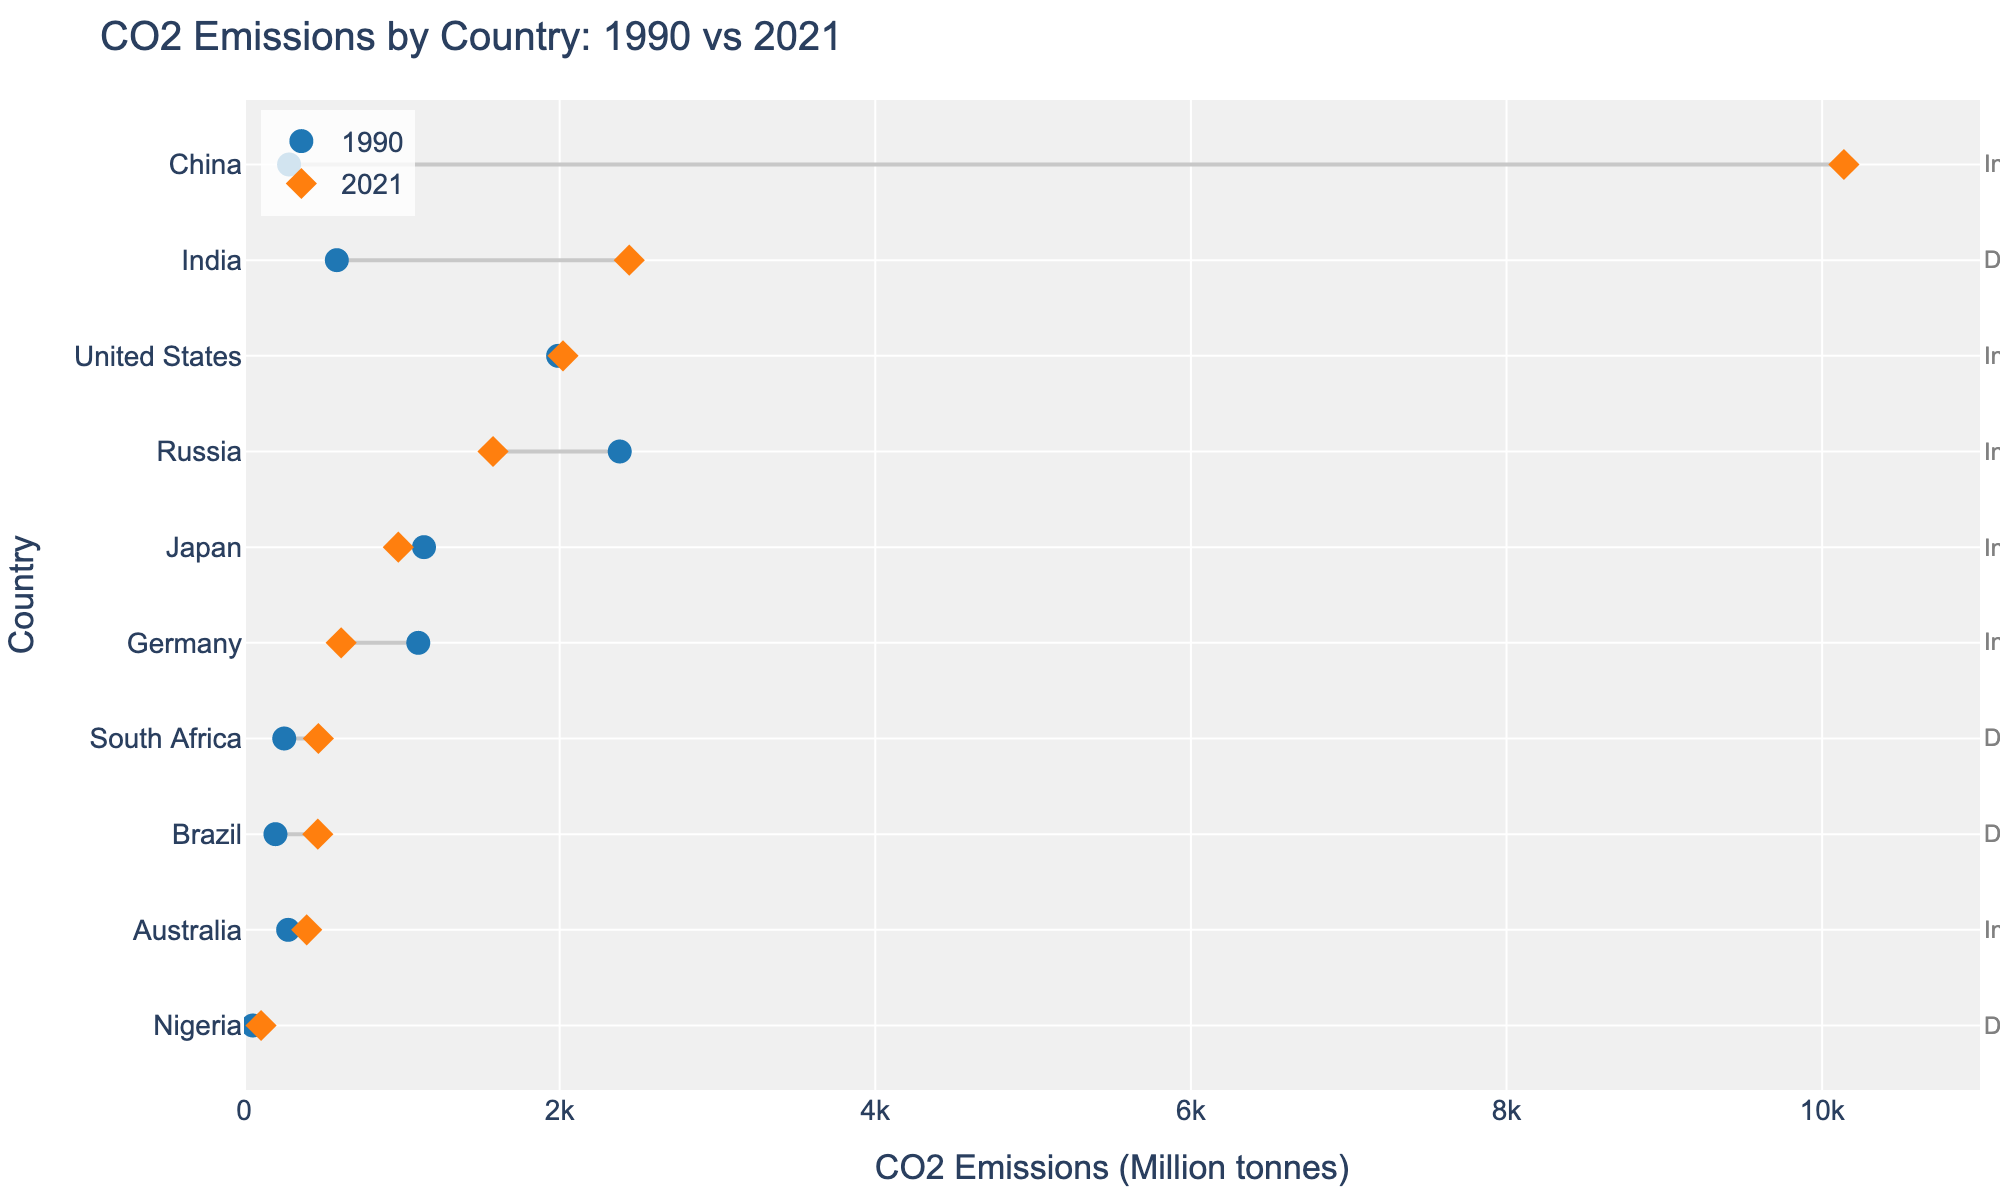What is the title of the plot? The title of the plot is written at the top and reads "CO2 Emissions by Country: 1990 vs 2021".
Answer: CO2 Emissions by Country: 1990 vs 2021 Which country had the highest CO2 emissions in 2021? By looking at the position on the x-axis, China is the farthest right on the plot, indicating it had the highest CO2 emissions in 2021.
Answer: China What is the color of the markers indicating CO2 emissions in 1990? The markers for 1990 are a specific shade of blue, which differentiates them from other data points.
Answer: Blue How many countries have been categorized as developing? The plot shows country annotations on the far right side of the plot. Counting the annotations labeled "Developing" gives us the total number of those countries.
Answer: 4 Which country had the largest increase in CO2 emissions between 1990 and 2021? To find the largest increase, we look at the length of the lines connecting the blue and orange markers. China has the longest line, indicating the biggest increase.
Answer: China Which industrial country reduced its CO2 emissions from 1990 to 2021? Identifying the countries with downward-sloping lines (from left to right) among those labeled as "Industrial" reveals Germany as the country that reduced its emissions.
Answer: Germany Between Brazil and South Africa, which country had a higher CO2 emission in 1990? By comparing the blue markers for Brazil and South Africa on the x-axis, Brazil's point appears further to the right, indicating higher emissions.
Answer: Brazil What is the difference in CO2 emissions between Russia and the United States in 1990? The plot shows the 1990 emissions for both countries. Subtract the values to find the difference: 2380.80 (Russia) - 1990.24 (United States).
Answer: 390.56 Which developing country had the smallest increase in CO2 emissions between 1990 and 2021? Observing the length of the lines for developing countries, Nigeria shows the shortest line, indicating the smallest increase.
Answer: Nigeria Which country had CO2 emissions closest to 600 million tonnes in 2021? The plot indicates 2021 emissions with orange markers. Germany’s marker is closest to 600 million tonnes.
Answer: Germany 